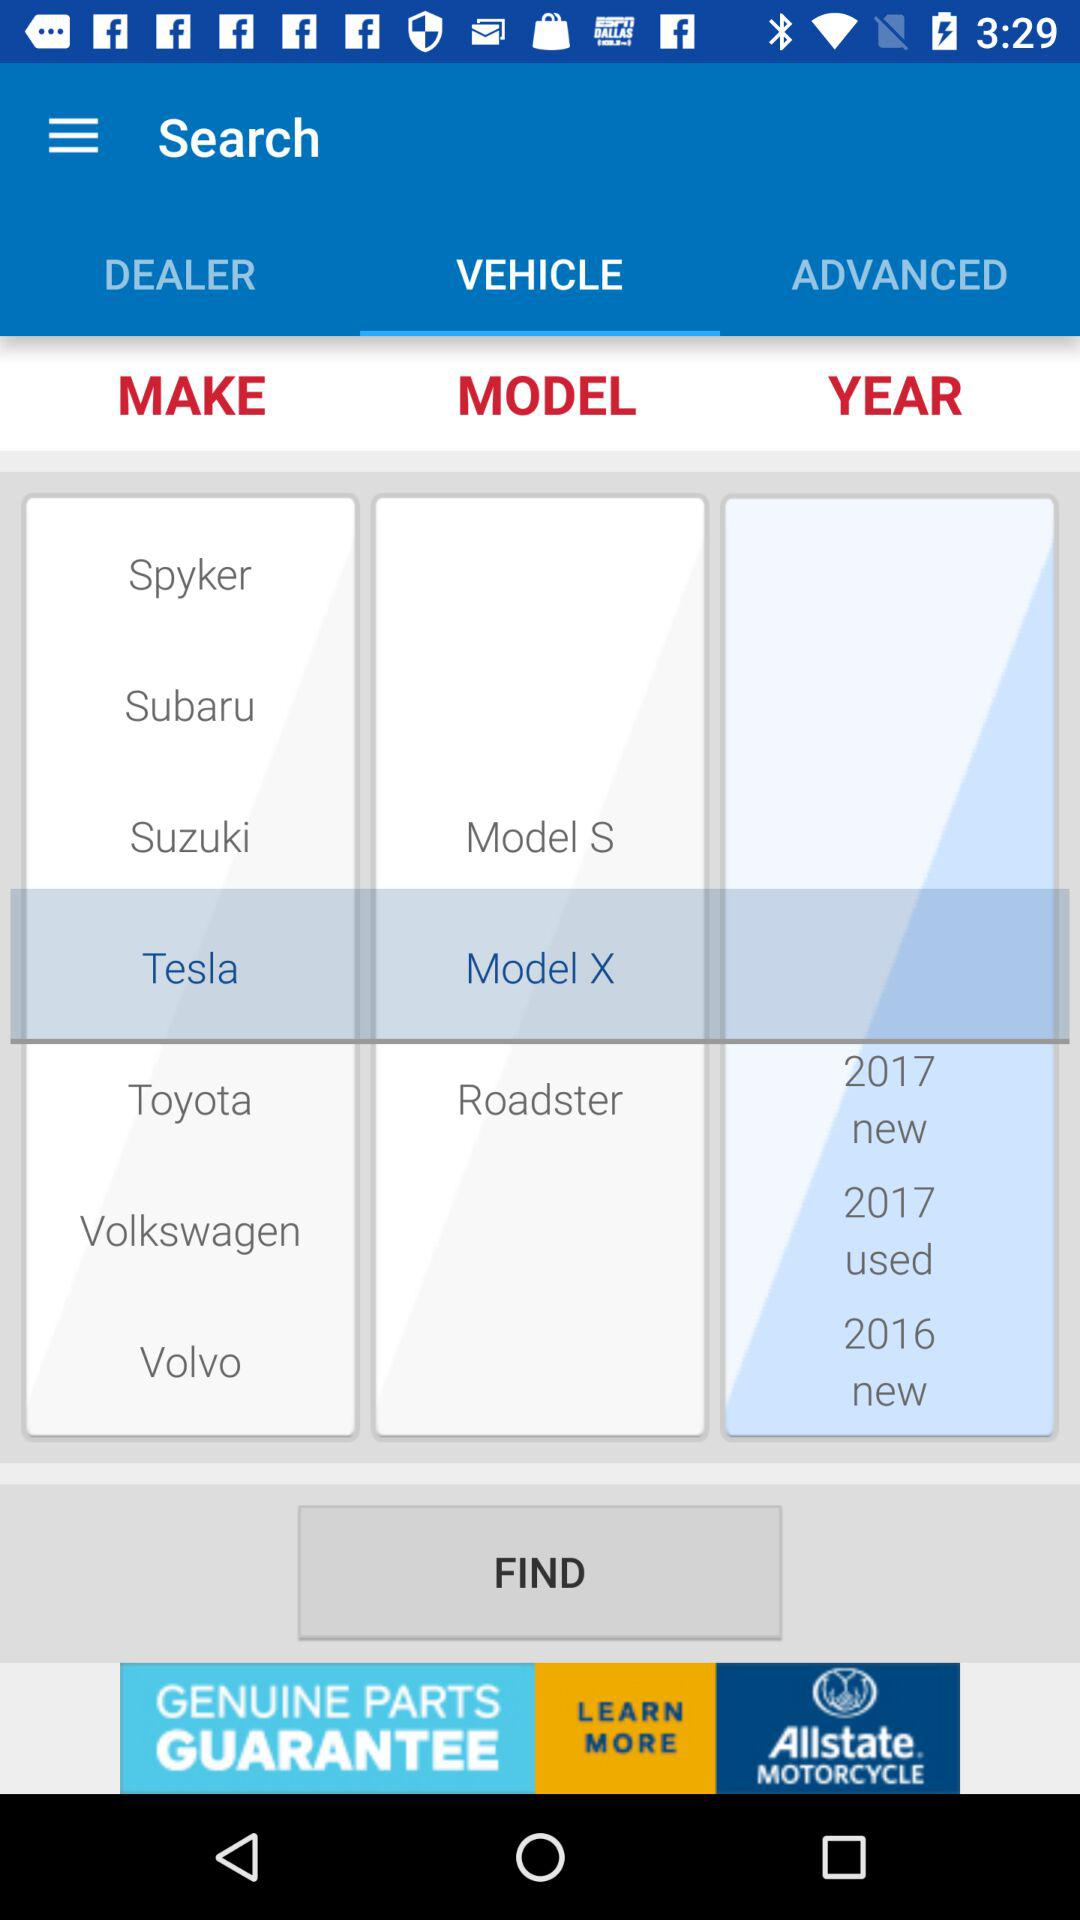Which tab has been selected? The selected tab is "VEHICLE". 